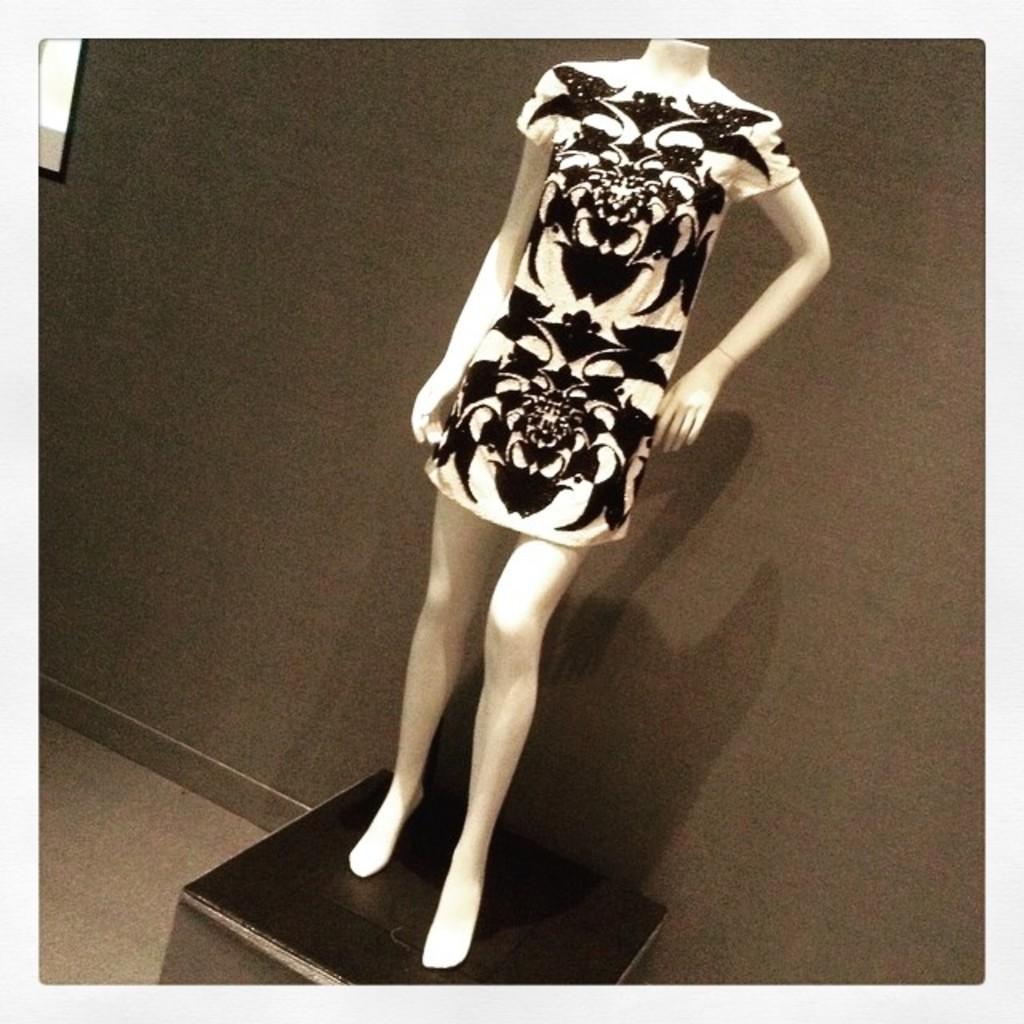Could you give a brief overview of what you see in this image? In this image we can see a black and white color dress to the mannequin on the box and wall in the background. 